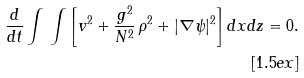<formula> <loc_0><loc_0><loc_500><loc_500>\frac { d } { d t } \int \, \int \left [ v ^ { 2 } + \frac { g ^ { 2 } } { N ^ { 2 } } \, \rho ^ { 2 } + | \nabla \psi | ^ { 2 } \right ] d x d z = 0 . \\ [ 1 . 5 e x ]</formula> 